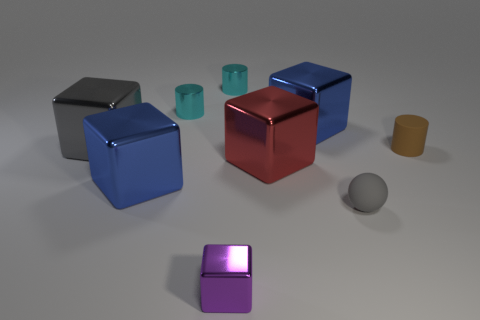Subtract 1 cubes. How many cubes are left? 4 Subtract all small purple metal blocks. How many blocks are left? 4 Subtract all gray blocks. How many blocks are left? 4 Subtract all green cubes. Subtract all brown cylinders. How many cubes are left? 5 Add 1 tiny brown objects. How many objects exist? 10 Subtract all blocks. How many objects are left? 4 Subtract all tiny gray rubber balls. Subtract all gray metallic blocks. How many objects are left? 7 Add 8 big red objects. How many big red objects are left? 9 Add 2 tiny cubes. How many tiny cubes exist? 3 Subtract 0 red cylinders. How many objects are left? 9 